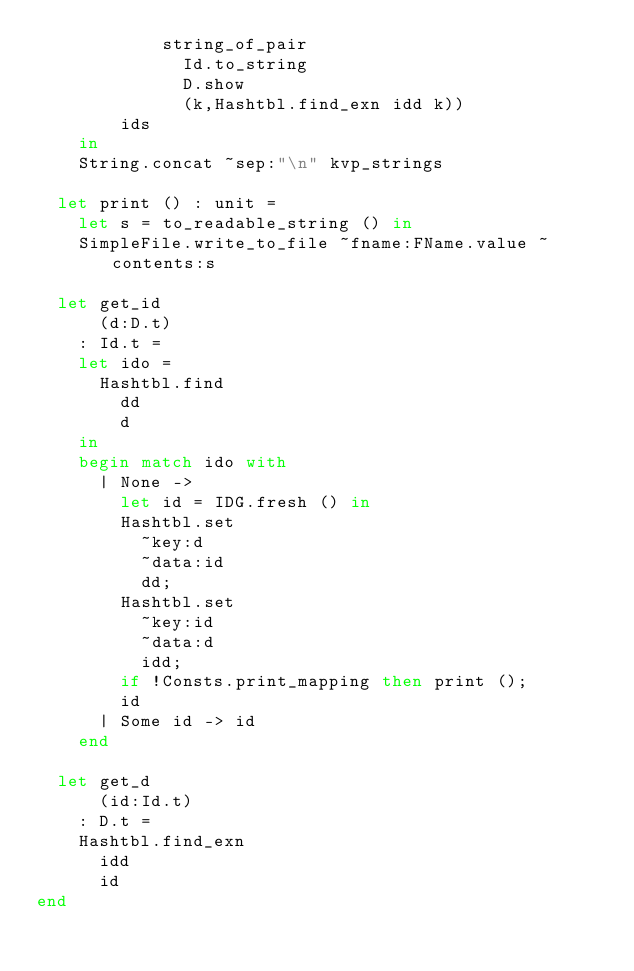Convert code to text. <code><loc_0><loc_0><loc_500><loc_500><_OCaml_>            string_of_pair
              Id.to_string
              D.show
              (k,Hashtbl.find_exn idd k))
        ids
    in
    String.concat ~sep:"\n" kvp_strings

  let print () : unit =
    let s = to_readable_string () in
    SimpleFile.write_to_file ~fname:FName.value ~contents:s

  let get_id
      (d:D.t)
    : Id.t =
    let ido =
      Hashtbl.find
        dd
        d
    in
    begin match ido with
      | None ->
        let id = IDG.fresh () in
        Hashtbl.set
          ~key:d
          ~data:id
          dd;
        Hashtbl.set
          ~key:id
          ~data:d
          idd;
        if !Consts.print_mapping then print ();
        id
      | Some id -> id
    end

  let get_d
      (id:Id.t)
    : D.t =
    Hashtbl.find_exn
      idd
      id
end
</code> 